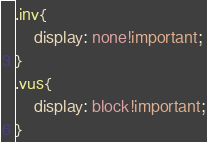<code> <loc_0><loc_0><loc_500><loc_500><_CSS_>

.inv{
    display: none!important;
}
.vus{
    display: block!important;
}</code> 